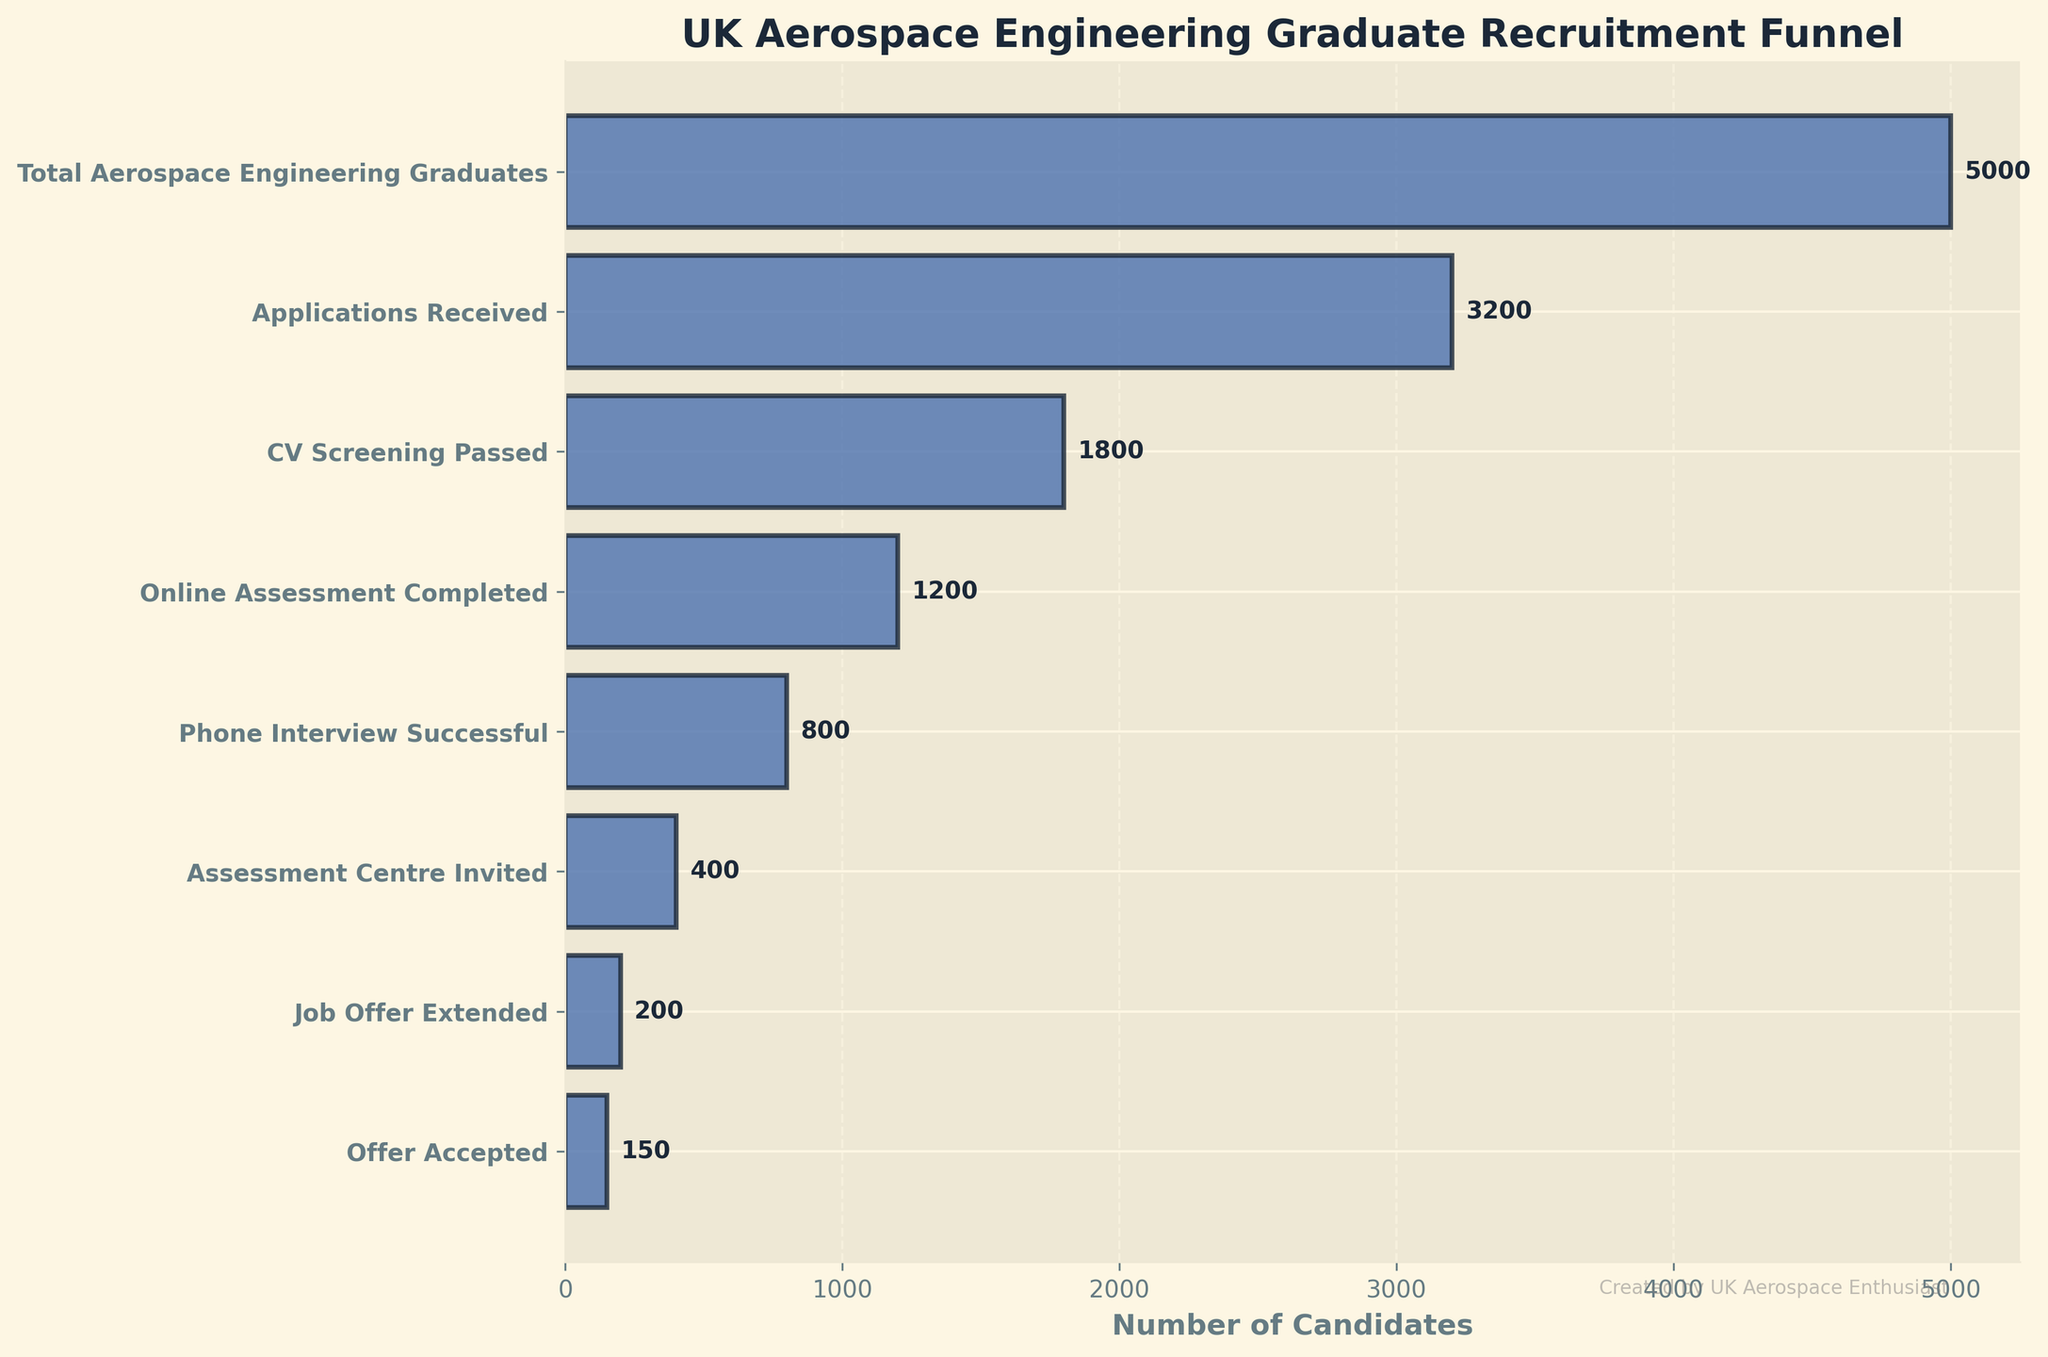How many aerospace engineering graduates accepted the job offer? We need to look at the last segment of the funnel chart labeled "Offer Accepted." The number next to it represents the candidates who accepted the job offer.
Answer: 150 What is the title of the chart? The title of the chart is usually displayed at the top of the chart. Check the top-center part of the chart to find the exact title text.
Answer: UK Aerospace Engineering Graduate Recruitment Funnel How many candidates passed the CV screening? Look at the segment labeled "CV Screening Passed" to find the number indicated next to it.
Answer: 1800 What is the difference between the number of candidates who received job offers and those who accepted them? To find the difference, subtract the number of candidates who accepted the job offer from the number who received job offers. According to the chart, the difference is 200 - 150.
Answer: 50 Which stage has the highest drop-off of candidates? The highest drop-off can be calculated by finding the stage with the largest decrease in the number of candidates from one stage to the next. Comparing the differences between successive stages, the largest drop-off is from "Total Aerospace Engineering Graduates" to "Applications Received" (5000 - 3200).
Answer: Total Aerospace Engineering Graduates to Applications Received What is the ratio of candidates invited to the assessment center to those receiving a job offer? To find the ratio, divide the number of candidates invited to the assessment center by the number of candidates receiving a job offer (400/200).
Answer: 2:1 How does the number of candidates who completed the online assessment compare to those who passed the phone interview? To compare the numbers, check the values next to "Online Assessment Completed" and "Phone Interview Successful." There are 1200 candidates who completed the online assessment and 800 who passed the phone interview.
Answer: Online Assessment Completed is greater than Phone Interview Successful What is the conversion rate from applications received to job offers extended? To determine the conversion rate, divide the number of job offers extended by the number of applications received and multiply by 100. The formula is (200/3200) * 100.
Answer: 6.25% Which stage shows the smallest decrease in candidate numbers from one stage to the next? By comparing the decreases between successive stages, the smallest decrease is between "Job Offer Extended" and "Offer Accepted" (200 - 150).
Answer: Job Offer Extended to Offer Accepted How many more candidates passed the online assessment than those invited to the assessment center? Subtract the number of candidates invited to the assessment center from the number who completed the online assessment (1200 - 400).
Answer: 800 